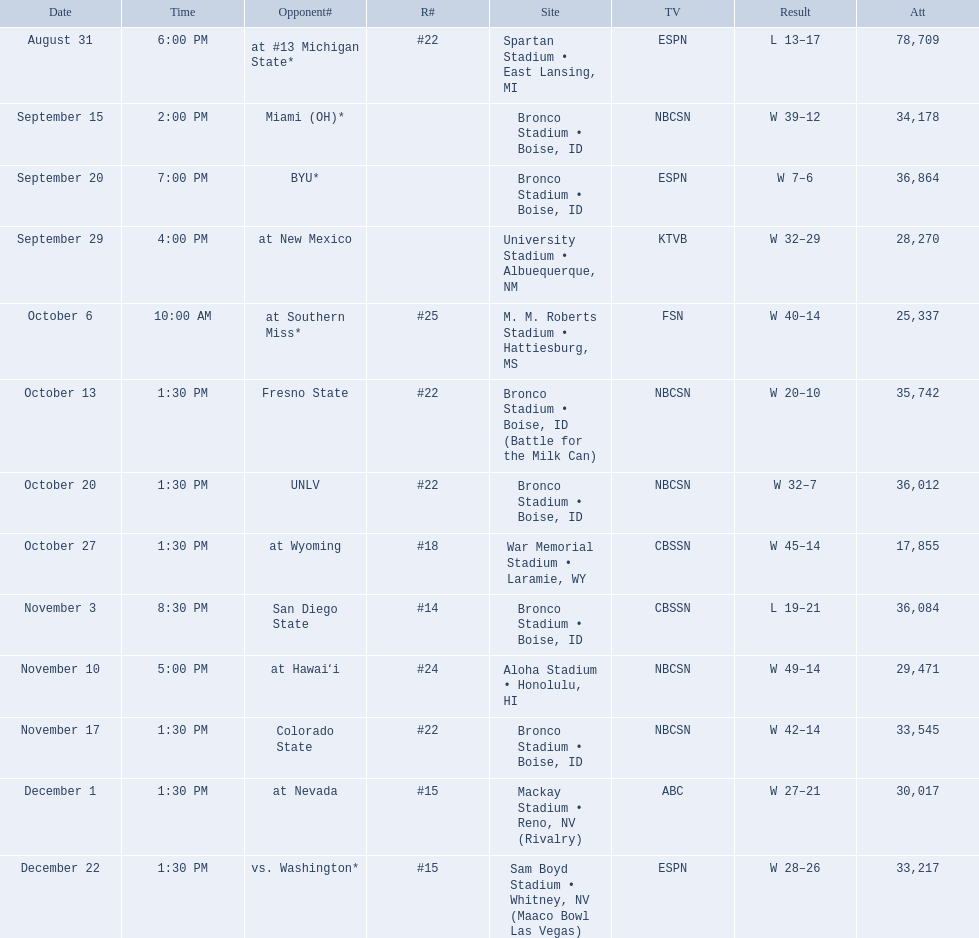Who were all the opponents for boise state? At #13 michigan state*, miami (oh)*, byu*, at new mexico, at southern miss*, fresno state, unlv, at wyoming, san diego state, at hawaiʻi, colorado state, at nevada, vs. washington*. Which opponents were ranked? At #13 michigan state*, #22, at southern miss*, #25, fresno state, #22, unlv, #22, at wyoming, #18, san diego state, #14. Which opponent had the highest rank? San Diego State. 